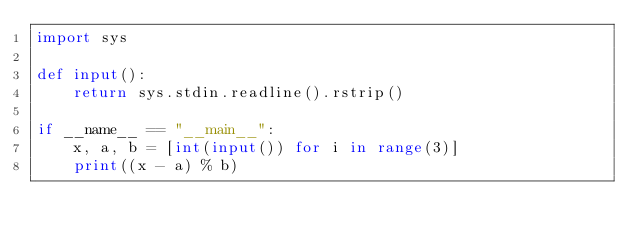Convert code to text. <code><loc_0><loc_0><loc_500><loc_500><_Python_>import sys

def input():
    return sys.stdin.readline().rstrip()

if __name__ == "__main__":
    x, a, b = [int(input()) for i in range(3)]
    print((x - a) % b)
</code> 